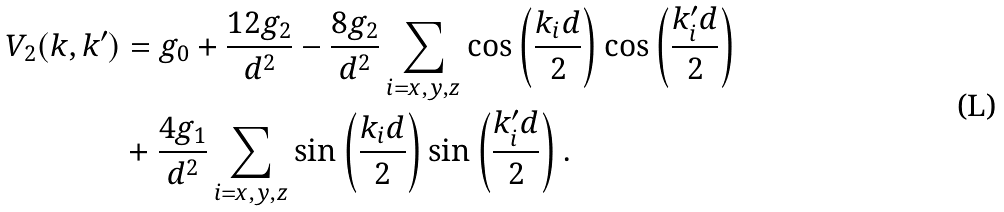Convert formula to latex. <formula><loc_0><loc_0><loc_500><loc_500>V _ { 2 } ( k , k ^ { \prime } ) & = g _ { 0 } + \frac { 1 2 g _ { 2 } } { d ^ { 2 } } - \frac { 8 g _ { 2 } } { d ^ { 2 } } \sum _ { i = x , y , z } \cos \left ( \frac { k _ { i } d } { 2 } \right ) \cos \left ( \frac { k _ { i } ^ { \prime } d } { 2 } \right ) \\ & + \frac { 4 g _ { 1 } } { d ^ { 2 } } \sum _ { i = x , y , z } \sin \left ( \frac { k _ { i } d } { 2 } \right ) \sin \left ( \frac { k _ { i } ^ { \prime } d } { 2 } \right ) .</formula> 